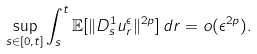<formula> <loc_0><loc_0><loc_500><loc_500>\sup _ { s \in [ 0 , t ] } \int _ { s } ^ { t } \mathbb { E } [ \| D _ { s } ^ { 1 } u _ { r } ^ { \epsilon } \| ^ { 2 p } ] \, d r = o ( \epsilon ^ { 2 p } ) .</formula> 